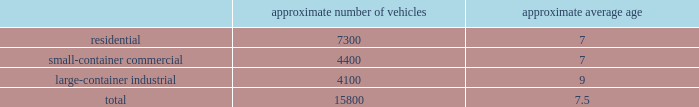Acquire operations and facilities from municipalities and other local governments , as they increasingly seek to raise capital and reduce risk .
We realize synergies from consolidating businesses into our existing operations , whether through acquisitions or public-private partnerships , which allow us to reduce capital and expense requirements associated with truck routing , personnel , fleet maintenance , inventories and back-office administration .
Operating model the goal of our operating model pillar is to deliver a consistent , high quality service to all of our customers through the republic way : one way .
Everywhere .
Every day .
This approach of developing standardized processes with rigorous controls and tracking allows us to leverage our scale and deliver durable operational excellence .
The republic way is the key to harnessing the best of what we do as operators and translating that across all facets of our business .
A key enabler of the republic way is our organizational structure that fosters a high performance culture by maintaining 360 degree accountability and full profit and loss responsibility with local management , supported by a functional structure to provide subject matter expertise .
This structure allows us to take advantage of our scale by coordinating functionally across all of our markets , while empowering local management to respond to unique market dynamics .
We have rolled out several productivity and cost control initiatives designed to deliver the best service possible to our customers in the most efficient and environmentally sound way .
Fleet automation approximately 74% ( 74 % ) of our residential routes have been converted to automated single driver trucks .
By converting our residential routes to automated service , we reduce labor costs , improve driver productivity , decrease emissions and create a safer work environment for our employees .
Additionally , communities using automated vehicles have higher participation rates in recycling programs , thereby complementing our initiative to expand our recycling capabilities .
Fleet conversion to compressed natural gas ( cng ) approximately 18% ( 18 % ) of our fleet operates on natural gas .
We expect to continue our gradual fleet conversion to cng , our preferred alternative fuel technology , as part of our ordinary annual fleet replacement process .
We believe a gradual fleet conversion is most prudent to realize the full value of our previous fleet investments .
Approximately 36% ( 36 % ) of our replacement vehicle purchases during 2016 were cng vehicles .
We believe using cng vehicles provides us a competitive advantage in communities with strict clean emission initiatives that focus on protecting the environment .
Although upfront capital costs are higher , using cng reduces our overall fleet operating costs through lower fuel expenses .
As of december 31 , 2016 , we operated 38 cng fueling stations .
Standardized maintenance based on an industry trade publication , we operate the eighth largest vocational fleet in the united states .
As of december 31 , 2016 , our average fleet age in years , by line of business , was as follows : approximate number of vehicles approximate average age .

As of december 312016 what was the ratio of the approximate number of residential vehicles to the large-container industrial? 
Rationale: for every large-container industrial there is 1.78 residential vehicles
Computations: (7300 / 4100)
Answer: 1.78049. 